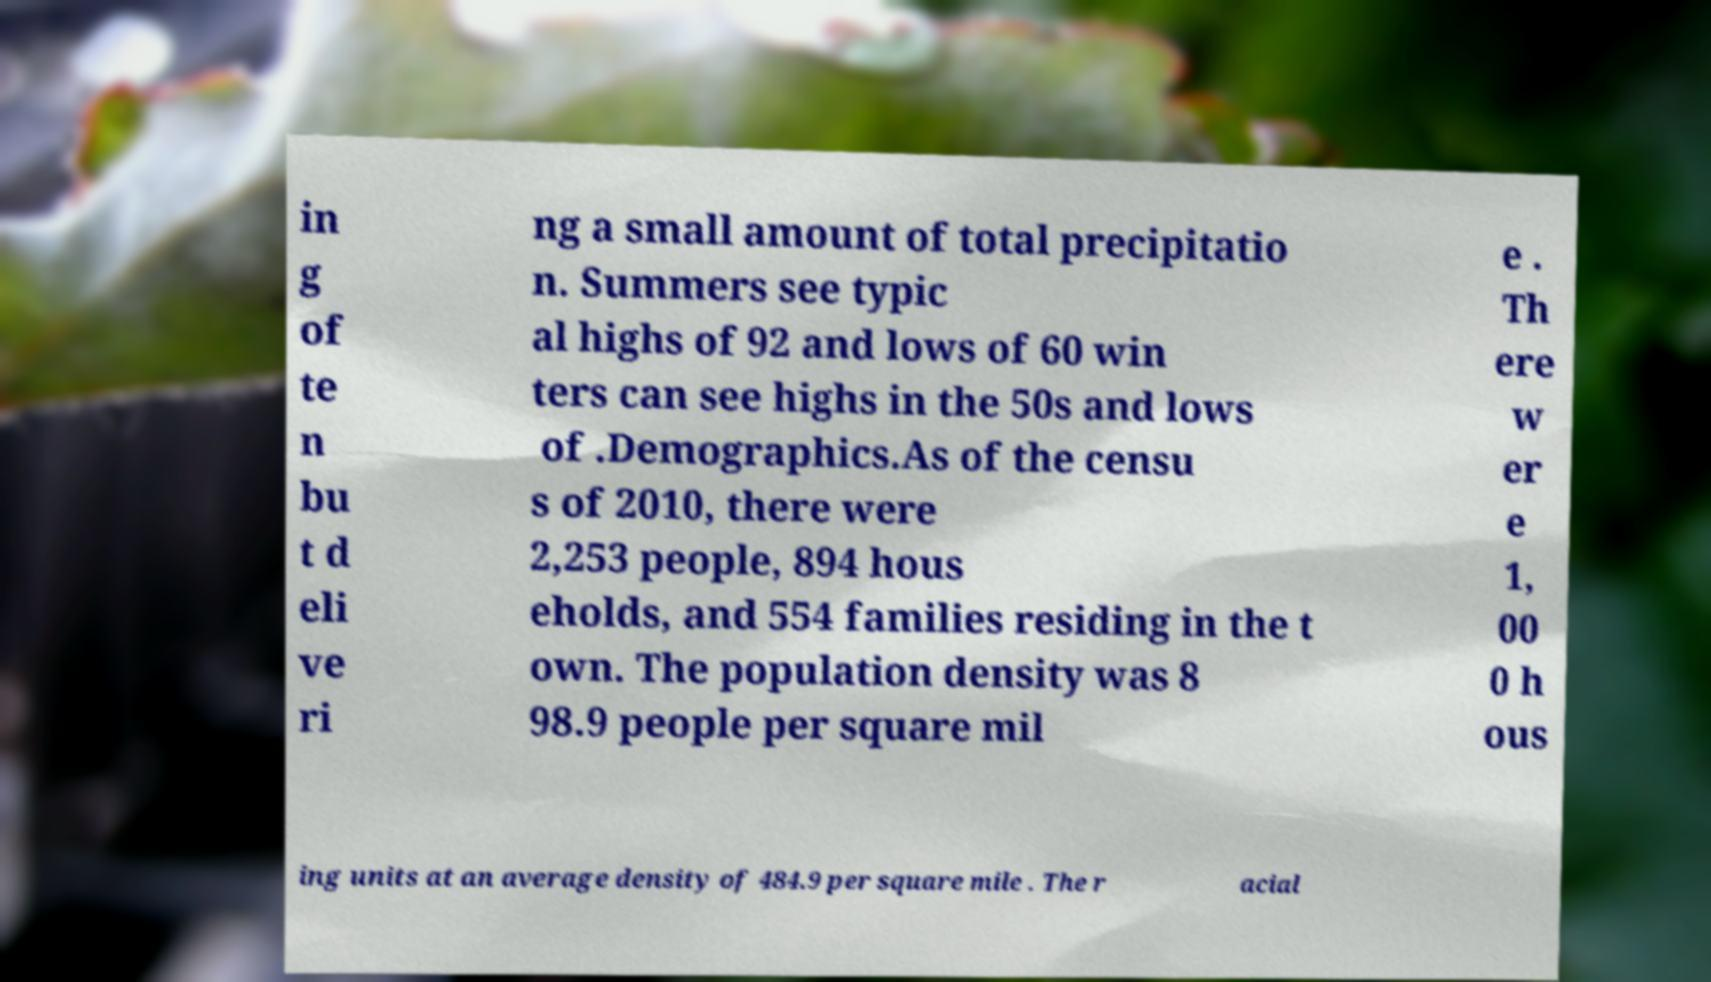What messages or text are displayed in this image? I need them in a readable, typed format. in g of te n bu t d eli ve ri ng a small amount of total precipitatio n. Summers see typic al highs of 92 and lows of 60 win ters can see highs in the 50s and lows of .Demographics.As of the censu s of 2010, there were 2,253 people, 894 hous eholds, and 554 families residing in the t own. The population density was 8 98.9 people per square mil e . Th ere w er e 1, 00 0 h ous ing units at an average density of 484.9 per square mile . The r acial 